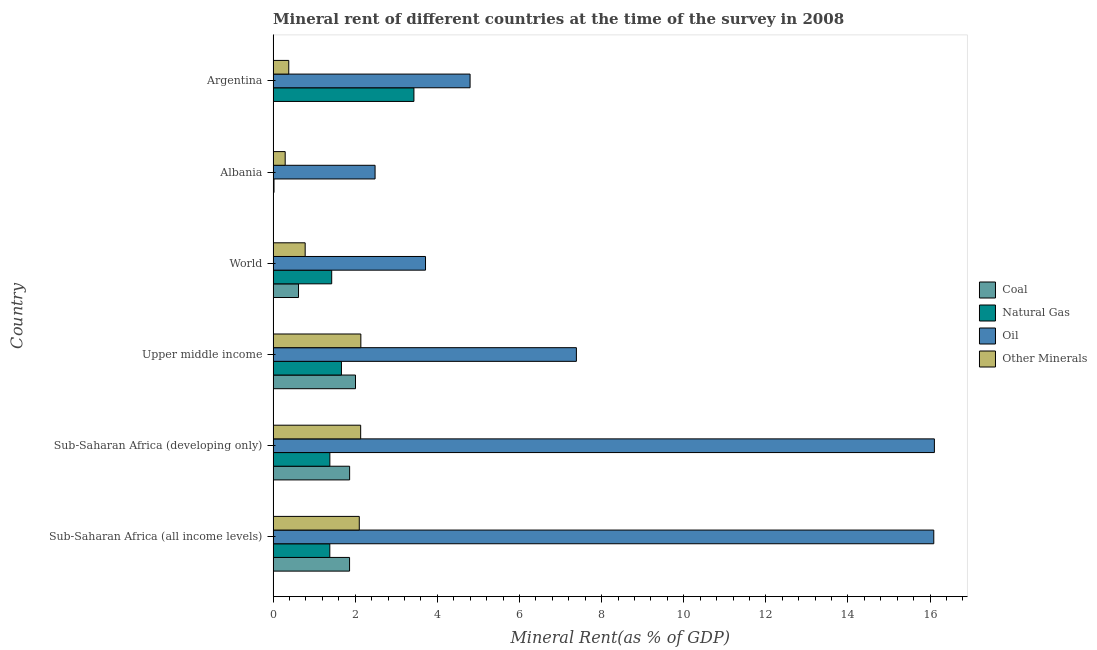How many groups of bars are there?
Your response must be concise. 6. Are the number of bars per tick equal to the number of legend labels?
Your answer should be very brief. Yes. What is the label of the 5th group of bars from the top?
Give a very brief answer. Sub-Saharan Africa (developing only). In how many cases, is the number of bars for a given country not equal to the number of legend labels?
Your answer should be very brief. 0. What is the coal rent in Albania?
Your answer should be very brief. 0. Across all countries, what is the maximum coal rent?
Your answer should be very brief. 2.01. Across all countries, what is the minimum coal rent?
Your response must be concise. 0. In which country was the  rent of other minerals maximum?
Your response must be concise. Upper middle income. In which country was the natural gas rent minimum?
Your response must be concise. Albania. What is the total  rent of other minerals in the graph?
Provide a short and direct response. 7.82. What is the difference between the  rent of other minerals in Argentina and that in Sub-Saharan Africa (all income levels)?
Your answer should be very brief. -1.72. What is the difference between the oil rent in Sub-Saharan Africa (developing only) and the coal rent in Upper middle income?
Provide a succinct answer. 14.1. What is the average oil rent per country?
Offer a very short reply. 8.43. What is the difference between the coal rent and natural gas rent in Sub-Saharan Africa (all income levels)?
Keep it short and to the point. 0.48. In how many countries, is the natural gas rent greater than 7.6 %?
Your answer should be compact. 0. What is the ratio of the oil rent in Sub-Saharan Africa (all income levels) to that in World?
Provide a short and direct response. 4.33. What is the difference between the highest and the second highest  rent of other minerals?
Keep it short and to the point. 0. In how many countries, is the  rent of other minerals greater than the average  rent of other minerals taken over all countries?
Keep it short and to the point. 3. Is the sum of the oil rent in Upper middle income and World greater than the maximum natural gas rent across all countries?
Give a very brief answer. Yes. What does the 1st bar from the top in Argentina represents?
Make the answer very short. Other Minerals. What does the 4th bar from the bottom in Sub-Saharan Africa (developing only) represents?
Provide a succinct answer. Other Minerals. Is it the case that in every country, the sum of the coal rent and natural gas rent is greater than the oil rent?
Provide a succinct answer. No. Are all the bars in the graph horizontal?
Provide a short and direct response. Yes. What is the difference between two consecutive major ticks on the X-axis?
Ensure brevity in your answer.  2. Does the graph contain any zero values?
Keep it short and to the point. No. How are the legend labels stacked?
Keep it short and to the point. Vertical. What is the title of the graph?
Your response must be concise. Mineral rent of different countries at the time of the survey in 2008. Does "Taxes on income" appear as one of the legend labels in the graph?
Your answer should be compact. No. What is the label or title of the X-axis?
Your response must be concise. Mineral Rent(as % of GDP). What is the Mineral Rent(as % of GDP) in Coal in Sub-Saharan Africa (all income levels)?
Offer a terse response. 1.86. What is the Mineral Rent(as % of GDP) in Natural Gas in Sub-Saharan Africa (all income levels)?
Your answer should be very brief. 1.38. What is the Mineral Rent(as % of GDP) in Oil in Sub-Saharan Africa (all income levels)?
Make the answer very short. 16.09. What is the Mineral Rent(as % of GDP) in Other Minerals in Sub-Saharan Africa (all income levels)?
Your response must be concise. 2.1. What is the Mineral Rent(as % of GDP) in Coal in Sub-Saharan Africa (developing only)?
Offer a very short reply. 1.86. What is the Mineral Rent(as % of GDP) in Natural Gas in Sub-Saharan Africa (developing only)?
Offer a terse response. 1.38. What is the Mineral Rent(as % of GDP) of Oil in Sub-Saharan Africa (developing only)?
Offer a very short reply. 16.1. What is the Mineral Rent(as % of GDP) of Other Minerals in Sub-Saharan Africa (developing only)?
Make the answer very short. 2.13. What is the Mineral Rent(as % of GDP) in Coal in Upper middle income?
Your response must be concise. 2.01. What is the Mineral Rent(as % of GDP) in Natural Gas in Upper middle income?
Make the answer very short. 1.66. What is the Mineral Rent(as % of GDP) in Oil in Upper middle income?
Provide a short and direct response. 7.39. What is the Mineral Rent(as % of GDP) of Other Minerals in Upper middle income?
Ensure brevity in your answer.  2.14. What is the Mineral Rent(as % of GDP) in Coal in World?
Your answer should be compact. 0.62. What is the Mineral Rent(as % of GDP) in Natural Gas in World?
Your answer should be compact. 1.43. What is the Mineral Rent(as % of GDP) of Oil in World?
Your answer should be compact. 3.71. What is the Mineral Rent(as % of GDP) in Other Minerals in World?
Your answer should be compact. 0.78. What is the Mineral Rent(as % of GDP) in Coal in Albania?
Offer a terse response. 0. What is the Mineral Rent(as % of GDP) of Natural Gas in Albania?
Offer a terse response. 0.02. What is the Mineral Rent(as % of GDP) of Oil in Albania?
Your answer should be very brief. 2.48. What is the Mineral Rent(as % of GDP) of Other Minerals in Albania?
Ensure brevity in your answer.  0.29. What is the Mineral Rent(as % of GDP) of Coal in Argentina?
Your answer should be compact. 0. What is the Mineral Rent(as % of GDP) of Natural Gas in Argentina?
Ensure brevity in your answer.  3.43. What is the Mineral Rent(as % of GDP) in Oil in Argentina?
Your answer should be compact. 4.8. What is the Mineral Rent(as % of GDP) of Other Minerals in Argentina?
Your answer should be very brief. 0.38. Across all countries, what is the maximum Mineral Rent(as % of GDP) in Coal?
Your response must be concise. 2.01. Across all countries, what is the maximum Mineral Rent(as % of GDP) of Natural Gas?
Give a very brief answer. 3.43. Across all countries, what is the maximum Mineral Rent(as % of GDP) of Oil?
Give a very brief answer. 16.1. Across all countries, what is the maximum Mineral Rent(as % of GDP) of Other Minerals?
Make the answer very short. 2.14. Across all countries, what is the minimum Mineral Rent(as % of GDP) of Coal?
Offer a very short reply. 0. Across all countries, what is the minimum Mineral Rent(as % of GDP) in Natural Gas?
Ensure brevity in your answer.  0.02. Across all countries, what is the minimum Mineral Rent(as % of GDP) of Oil?
Give a very brief answer. 2.48. Across all countries, what is the minimum Mineral Rent(as % of GDP) in Other Minerals?
Offer a very short reply. 0.29. What is the total Mineral Rent(as % of GDP) of Coal in the graph?
Your response must be concise. 6.36. What is the total Mineral Rent(as % of GDP) in Natural Gas in the graph?
Provide a succinct answer. 9.3. What is the total Mineral Rent(as % of GDP) in Oil in the graph?
Offer a very short reply. 50.57. What is the total Mineral Rent(as % of GDP) of Other Minerals in the graph?
Provide a short and direct response. 7.82. What is the difference between the Mineral Rent(as % of GDP) of Coal in Sub-Saharan Africa (all income levels) and that in Sub-Saharan Africa (developing only)?
Give a very brief answer. -0. What is the difference between the Mineral Rent(as % of GDP) of Natural Gas in Sub-Saharan Africa (all income levels) and that in Sub-Saharan Africa (developing only)?
Provide a succinct answer. -0. What is the difference between the Mineral Rent(as % of GDP) of Oil in Sub-Saharan Africa (all income levels) and that in Sub-Saharan Africa (developing only)?
Ensure brevity in your answer.  -0.02. What is the difference between the Mineral Rent(as % of GDP) in Other Minerals in Sub-Saharan Africa (all income levels) and that in Sub-Saharan Africa (developing only)?
Your response must be concise. -0.03. What is the difference between the Mineral Rent(as % of GDP) in Coal in Sub-Saharan Africa (all income levels) and that in Upper middle income?
Give a very brief answer. -0.14. What is the difference between the Mineral Rent(as % of GDP) of Natural Gas in Sub-Saharan Africa (all income levels) and that in Upper middle income?
Offer a terse response. -0.28. What is the difference between the Mineral Rent(as % of GDP) in Oil in Sub-Saharan Africa (all income levels) and that in Upper middle income?
Keep it short and to the point. 8.7. What is the difference between the Mineral Rent(as % of GDP) of Other Minerals in Sub-Saharan Africa (all income levels) and that in Upper middle income?
Ensure brevity in your answer.  -0.04. What is the difference between the Mineral Rent(as % of GDP) in Coal in Sub-Saharan Africa (all income levels) and that in World?
Provide a succinct answer. 1.24. What is the difference between the Mineral Rent(as % of GDP) in Natural Gas in Sub-Saharan Africa (all income levels) and that in World?
Your response must be concise. -0.05. What is the difference between the Mineral Rent(as % of GDP) of Oil in Sub-Saharan Africa (all income levels) and that in World?
Make the answer very short. 12.38. What is the difference between the Mineral Rent(as % of GDP) in Other Minerals in Sub-Saharan Africa (all income levels) and that in World?
Provide a succinct answer. 1.32. What is the difference between the Mineral Rent(as % of GDP) in Coal in Sub-Saharan Africa (all income levels) and that in Albania?
Your answer should be compact. 1.86. What is the difference between the Mineral Rent(as % of GDP) in Natural Gas in Sub-Saharan Africa (all income levels) and that in Albania?
Keep it short and to the point. 1.36. What is the difference between the Mineral Rent(as % of GDP) of Oil in Sub-Saharan Africa (all income levels) and that in Albania?
Your answer should be very brief. 13.61. What is the difference between the Mineral Rent(as % of GDP) in Other Minerals in Sub-Saharan Africa (all income levels) and that in Albania?
Your answer should be compact. 1.8. What is the difference between the Mineral Rent(as % of GDP) in Coal in Sub-Saharan Africa (all income levels) and that in Argentina?
Ensure brevity in your answer.  1.86. What is the difference between the Mineral Rent(as % of GDP) in Natural Gas in Sub-Saharan Africa (all income levels) and that in Argentina?
Your answer should be very brief. -2.05. What is the difference between the Mineral Rent(as % of GDP) in Oil in Sub-Saharan Africa (all income levels) and that in Argentina?
Offer a terse response. 11.29. What is the difference between the Mineral Rent(as % of GDP) of Other Minerals in Sub-Saharan Africa (all income levels) and that in Argentina?
Your response must be concise. 1.72. What is the difference between the Mineral Rent(as % of GDP) in Coal in Sub-Saharan Africa (developing only) and that in Upper middle income?
Keep it short and to the point. -0.14. What is the difference between the Mineral Rent(as % of GDP) of Natural Gas in Sub-Saharan Africa (developing only) and that in Upper middle income?
Your answer should be very brief. -0.28. What is the difference between the Mineral Rent(as % of GDP) in Oil in Sub-Saharan Africa (developing only) and that in Upper middle income?
Provide a succinct answer. 8.72. What is the difference between the Mineral Rent(as % of GDP) in Other Minerals in Sub-Saharan Africa (developing only) and that in Upper middle income?
Provide a succinct answer. -0. What is the difference between the Mineral Rent(as % of GDP) of Coal in Sub-Saharan Africa (developing only) and that in World?
Your answer should be very brief. 1.24. What is the difference between the Mineral Rent(as % of GDP) in Natural Gas in Sub-Saharan Africa (developing only) and that in World?
Ensure brevity in your answer.  -0.04. What is the difference between the Mineral Rent(as % of GDP) in Oil in Sub-Saharan Africa (developing only) and that in World?
Your answer should be compact. 12.39. What is the difference between the Mineral Rent(as % of GDP) in Other Minerals in Sub-Saharan Africa (developing only) and that in World?
Ensure brevity in your answer.  1.35. What is the difference between the Mineral Rent(as % of GDP) of Coal in Sub-Saharan Africa (developing only) and that in Albania?
Give a very brief answer. 1.86. What is the difference between the Mineral Rent(as % of GDP) in Natural Gas in Sub-Saharan Africa (developing only) and that in Albania?
Ensure brevity in your answer.  1.36. What is the difference between the Mineral Rent(as % of GDP) of Oil in Sub-Saharan Africa (developing only) and that in Albania?
Ensure brevity in your answer.  13.62. What is the difference between the Mineral Rent(as % of GDP) in Other Minerals in Sub-Saharan Africa (developing only) and that in Albania?
Make the answer very short. 1.84. What is the difference between the Mineral Rent(as % of GDP) of Coal in Sub-Saharan Africa (developing only) and that in Argentina?
Keep it short and to the point. 1.86. What is the difference between the Mineral Rent(as % of GDP) in Natural Gas in Sub-Saharan Africa (developing only) and that in Argentina?
Offer a terse response. -2.05. What is the difference between the Mineral Rent(as % of GDP) of Oil in Sub-Saharan Africa (developing only) and that in Argentina?
Offer a terse response. 11.31. What is the difference between the Mineral Rent(as % of GDP) in Other Minerals in Sub-Saharan Africa (developing only) and that in Argentina?
Provide a succinct answer. 1.75. What is the difference between the Mineral Rent(as % of GDP) of Coal in Upper middle income and that in World?
Provide a succinct answer. 1.39. What is the difference between the Mineral Rent(as % of GDP) in Natural Gas in Upper middle income and that in World?
Ensure brevity in your answer.  0.24. What is the difference between the Mineral Rent(as % of GDP) of Oil in Upper middle income and that in World?
Your answer should be compact. 3.67. What is the difference between the Mineral Rent(as % of GDP) of Other Minerals in Upper middle income and that in World?
Your answer should be very brief. 1.36. What is the difference between the Mineral Rent(as % of GDP) of Coal in Upper middle income and that in Albania?
Your answer should be very brief. 2. What is the difference between the Mineral Rent(as % of GDP) of Natural Gas in Upper middle income and that in Albania?
Offer a terse response. 1.64. What is the difference between the Mineral Rent(as % of GDP) of Oil in Upper middle income and that in Albania?
Make the answer very short. 4.9. What is the difference between the Mineral Rent(as % of GDP) in Other Minerals in Upper middle income and that in Albania?
Give a very brief answer. 1.84. What is the difference between the Mineral Rent(as % of GDP) of Coal in Upper middle income and that in Argentina?
Give a very brief answer. 2. What is the difference between the Mineral Rent(as % of GDP) in Natural Gas in Upper middle income and that in Argentina?
Provide a short and direct response. -1.77. What is the difference between the Mineral Rent(as % of GDP) in Oil in Upper middle income and that in Argentina?
Provide a succinct answer. 2.59. What is the difference between the Mineral Rent(as % of GDP) in Other Minerals in Upper middle income and that in Argentina?
Provide a succinct answer. 1.76. What is the difference between the Mineral Rent(as % of GDP) of Coal in World and that in Albania?
Ensure brevity in your answer.  0.62. What is the difference between the Mineral Rent(as % of GDP) of Natural Gas in World and that in Albania?
Keep it short and to the point. 1.41. What is the difference between the Mineral Rent(as % of GDP) in Oil in World and that in Albania?
Make the answer very short. 1.23. What is the difference between the Mineral Rent(as % of GDP) of Other Minerals in World and that in Albania?
Ensure brevity in your answer.  0.49. What is the difference between the Mineral Rent(as % of GDP) in Coal in World and that in Argentina?
Provide a succinct answer. 0.62. What is the difference between the Mineral Rent(as % of GDP) in Natural Gas in World and that in Argentina?
Provide a short and direct response. -2. What is the difference between the Mineral Rent(as % of GDP) of Oil in World and that in Argentina?
Your answer should be very brief. -1.09. What is the difference between the Mineral Rent(as % of GDP) in Other Minerals in World and that in Argentina?
Provide a succinct answer. 0.4. What is the difference between the Mineral Rent(as % of GDP) in Coal in Albania and that in Argentina?
Provide a short and direct response. 0. What is the difference between the Mineral Rent(as % of GDP) in Natural Gas in Albania and that in Argentina?
Offer a very short reply. -3.41. What is the difference between the Mineral Rent(as % of GDP) in Oil in Albania and that in Argentina?
Make the answer very short. -2.31. What is the difference between the Mineral Rent(as % of GDP) in Other Minerals in Albania and that in Argentina?
Your answer should be very brief. -0.09. What is the difference between the Mineral Rent(as % of GDP) in Coal in Sub-Saharan Africa (all income levels) and the Mineral Rent(as % of GDP) in Natural Gas in Sub-Saharan Africa (developing only)?
Offer a terse response. 0.48. What is the difference between the Mineral Rent(as % of GDP) of Coal in Sub-Saharan Africa (all income levels) and the Mineral Rent(as % of GDP) of Oil in Sub-Saharan Africa (developing only)?
Make the answer very short. -14.24. What is the difference between the Mineral Rent(as % of GDP) in Coal in Sub-Saharan Africa (all income levels) and the Mineral Rent(as % of GDP) in Other Minerals in Sub-Saharan Africa (developing only)?
Make the answer very short. -0.27. What is the difference between the Mineral Rent(as % of GDP) in Natural Gas in Sub-Saharan Africa (all income levels) and the Mineral Rent(as % of GDP) in Oil in Sub-Saharan Africa (developing only)?
Provide a short and direct response. -14.72. What is the difference between the Mineral Rent(as % of GDP) in Natural Gas in Sub-Saharan Africa (all income levels) and the Mineral Rent(as % of GDP) in Other Minerals in Sub-Saharan Africa (developing only)?
Provide a succinct answer. -0.75. What is the difference between the Mineral Rent(as % of GDP) in Oil in Sub-Saharan Africa (all income levels) and the Mineral Rent(as % of GDP) in Other Minerals in Sub-Saharan Africa (developing only)?
Provide a succinct answer. 13.96. What is the difference between the Mineral Rent(as % of GDP) in Coal in Sub-Saharan Africa (all income levels) and the Mineral Rent(as % of GDP) in Natural Gas in Upper middle income?
Your answer should be very brief. 0.2. What is the difference between the Mineral Rent(as % of GDP) of Coal in Sub-Saharan Africa (all income levels) and the Mineral Rent(as % of GDP) of Oil in Upper middle income?
Provide a succinct answer. -5.52. What is the difference between the Mineral Rent(as % of GDP) in Coal in Sub-Saharan Africa (all income levels) and the Mineral Rent(as % of GDP) in Other Minerals in Upper middle income?
Make the answer very short. -0.27. What is the difference between the Mineral Rent(as % of GDP) of Natural Gas in Sub-Saharan Africa (all income levels) and the Mineral Rent(as % of GDP) of Oil in Upper middle income?
Ensure brevity in your answer.  -6.01. What is the difference between the Mineral Rent(as % of GDP) of Natural Gas in Sub-Saharan Africa (all income levels) and the Mineral Rent(as % of GDP) of Other Minerals in Upper middle income?
Give a very brief answer. -0.76. What is the difference between the Mineral Rent(as % of GDP) in Oil in Sub-Saharan Africa (all income levels) and the Mineral Rent(as % of GDP) in Other Minerals in Upper middle income?
Provide a succinct answer. 13.95. What is the difference between the Mineral Rent(as % of GDP) of Coal in Sub-Saharan Africa (all income levels) and the Mineral Rent(as % of GDP) of Natural Gas in World?
Your response must be concise. 0.43. What is the difference between the Mineral Rent(as % of GDP) in Coal in Sub-Saharan Africa (all income levels) and the Mineral Rent(as % of GDP) in Oil in World?
Your answer should be very brief. -1.85. What is the difference between the Mineral Rent(as % of GDP) in Coal in Sub-Saharan Africa (all income levels) and the Mineral Rent(as % of GDP) in Other Minerals in World?
Provide a short and direct response. 1.08. What is the difference between the Mineral Rent(as % of GDP) in Natural Gas in Sub-Saharan Africa (all income levels) and the Mineral Rent(as % of GDP) in Oil in World?
Provide a short and direct response. -2.33. What is the difference between the Mineral Rent(as % of GDP) in Oil in Sub-Saharan Africa (all income levels) and the Mineral Rent(as % of GDP) in Other Minerals in World?
Ensure brevity in your answer.  15.31. What is the difference between the Mineral Rent(as % of GDP) of Coal in Sub-Saharan Africa (all income levels) and the Mineral Rent(as % of GDP) of Natural Gas in Albania?
Your response must be concise. 1.84. What is the difference between the Mineral Rent(as % of GDP) in Coal in Sub-Saharan Africa (all income levels) and the Mineral Rent(as % of GDP) in Oil in Albania?
Keep it short and to the point. -0.62. What is the difference between the Mineral Rent(as % of GDP) of Coal in Sub-Saharan Africa (all income levels) and the Mineral Rent(as % of GDP) of Other Minerals in Albania?
Keep it short and to the point. 1.57. What is the difference between the Mineral Rent(as % of GDP) in Natural Gas in Sub-Saharan Africa (all income levels) and the Mineral Rent(as % of GDP) in Oil in Albania?
Your answer should be compact. -1.1. What is the difference between the Mineral Rent(as % of GDP) of Natural Gas in Sub-Saharan Africa (all income levels) and the Mineral Rent(as % of GDP) of Other Minerals in Albania?
Offer a very short reply. 1.09. What is the difference between the Mineral Rent(as % of GDP) of Oil in Sub-Saharan Africa (all income levels) and the Mineral Rent(as % of GDP) of Other Minerals in Albania?
Offer a very short reply. 15.8. What is the difference between the Mineral Rent(as % of GDP) in Coal in Sub-Saharan Africa (all income levels) and the Mineral Rent(as % of GDP) in Natural Gas in Argentina?
Your response must be concise. -1.57. What is the difference between the Mineral Rent(as % of GDP) in Coal in Sub-Saharan Africa (all income levels) and the Mineral Rent(as % of GDP) in Oil in Argentina?
Offer a very short reply. -2.94. What is the difference between the Mineral Rent(as % of GDP) in Coal in Sub-Saharan Africa (all income levels) and the Mineral Rent(as % of GDP) in Other Minerals in Argentina?
Ensure brevity in your answer.  1.48. What is the difference between the Mineral Rent(as % of GDP) in Natural Gas in Sub-Saharan Africa (all income levels) and the Mineral Rent(as % of GDP) in Oil in Argentina?
Your response must be concise. -3.42. What is the difference between the Mineral Rent(as % of GDP) in Natural Gas in Sub-Saharan Africa (all income levels) and the Mineral Rent(as % of GDP) in Other Minerals in Argentina?
Ensure brevity in your answer.  1. What is the difference between the Mineral Rent(as % of GDP) in Oil in Sub-Saharan Africa (all income levels) and the Mineral Rent(as % of GDP) in Other Minerals in Argentina?
Ensure brevity in your answer.  15.71. What is the difference between the Mineral Rent(as % of GDP) of Coal in Sub-Saharan Africa (developing only) and the Mineral Rent(as % of GDP) of Natural Gas in Upper middle income?
Provide a short and direct response. 0.2. What is the difference between the Mineral Rent(as % of GDP) of Coal in Sub-Saharan Africa (developing only) and the Mineral Rent(as % of GDP) of Oil in Upper middle income?
Offer a terse response. -5.52. What is the difference between the Mineral Rent(as % of GDP) of Coal in Sub-Saharan Africa (developing only) and the Mineral Rent(as % of GDP) of Other Minerals in Upper middle income?
Your response must be concise. -0.27. What is the difference between the Mineral Rent(as % of GDP) of Natural Gas in Sub-Saharan Africa (developing only) and the Mineral Rent(as % of GDP) of Oil in Upper middle income?
Provide a succinct answer. -6. What is the difference between the Mineral Rent(as % of GDP) in Natural Gas in Sub-Saharan Africa (developing only) and the Mineral Rent(as % of GDP) in Other Minerals in Upper middle income?
Offer a very short reply. -0.75. What is the difference between the Mineral Rent(as % of GDP) in Oil in Sub-Saharan Africa (developing only) and the Mineral Rent(as % of GDP) in Other Minerals in Upper middle income?
Provide a succinct answer. 13.97. What is the difference between the Mineral Rent(as % of GDP) in Coal in Sub-Saharan Africa (developing only) and the Mineral Rent(as % of GDP) in Natural Gas in World?
Offer a very short reply. 0.44. What is the difference between the Mineral Rent(as % of GDP) in Coal in Sub-Saharan Africa (developing only) and the Mineral Rent(as % of GDP) in Oil in World?
Offer a terse response. -1.85. What is the difference between the Mineral Rent(as % of GDP) in Coal in Sub-Saharan Africa (developing only) and the Mineral Rent(as % of GDP) in Other Minerals in World?
Provide a succinct answer. 1.08. What is the difference between the Mineral Rent(as % of GDP) in Natural Gas in Sub-Saharan Africa (developing only) and the Mineral Rent(as % of GDP) in Oil in World?
Keep it short and to the point. -2.33. What is the difference between the Mineral Rent(as % of GDP) of Natural Gas in Sub-Saharan Africa (developing only) and the Mineral Rent(as % of GDP) of Other Minerals in World?
Make the answer very short. 0.6. What is the difference between the Mineral Rent(as % of GDP) of Oil in Sub-Saharan Africa (developing only) and the Mineral Rent(as % of GDP) of Other Minerals in World?
Your response must be concise. 15.32. What is the difference between the Mineral Rent(as % of GDP) in Coal in Sub-Saharan Africa (developing only) and the Mineral Rent(as % of GDP) in Natural Gas in Albania?
Your answer should be very brief. 1.84. What is the difference between the Mineral Rent(as % of GDP) in Coal in Sub-Saharan Africa (developing only) and the Mineral Rent(as % of GDP) in Oil in Albania?
Your answer should be compact. -0.62. What is the difference between the Mineral Rent(as % of GDP) of Coal in Sub-Saharan Africa (developing only) and the Mineral Rent(as % of GDP) of Other Minerals in Albania?
Your answer should be very brief. 1.57. What is the difference between the Mineral Rent(as % of GDP) in Natural Gas in Sub-Saharan Africa (developing only) and the Mineral Rent(as % of GDP) in Oil in Albania?
Provide a short and direct response. -1.1. What is the difference between the Mineral Rent(as % of GDP) in Natural Gas in Sub-Saharan Africa (developing only) and the Mineral Rent(as % of GDP) in Other Minerals in Albania?
Provide a succinct answer. 1.09. What is the difference between the Mineral Rent(as % of GDP) in Oil in Sub-Saharan Africa (developing only) and the Mineral Rent(as % of GDP) in Other Minerals in Albania?
Your answer should be compact. 15.81. What is the difference between the Mineral Rent(as % of GDP) of Coal in Sub-Saharan Africa (developing only) and the Mineral Rent(as % of GDP) of Natural Gas in Argentina?
Offer a very short reply. -1.57. What is the difference between the Mineral Rent(as % of GDP) of Coal in Sub-Saharan Africa (developing only) and the Mineral Rent(as % of GDP) of Oil in Argentina?
Your answer should be very brief. -2.93. What is the difference between the Mineral Rent(as % of GDP) of Coal in Sub-Saharan Africa (developing only) and the Mineral Rent(as % of GDP) of Other Minerals in Argentina?
Offer a very short reply. 1.48. What is the difference between the Mineral Rent(as % of GDP) of Natural Gas in Sub-Saharan Africa (developing only) and the Mineral Rent(as % of GDP) of Oil in Argentina?
Give a very brief answer. -3.42. What is the difference between the Mineral Rent(as % of GDP) of Natural Gas in Sub-Saharan Africa (developing only) and the Mineral Rent(as % of GDP) of Other Minerals in Argentina?
Keep it short and to the point. 1. What is the difference between the Mineral Rent(as % of GDP) in Oil in Sub-Saharan Africa (developing only) and the Mineral Rent(as % of GDP) in Other Minerals in Argentina?
Offer a terse response. 15.72. What is the difference between the Mineral Rent(as % of GDP) in Coal in Upper middle income and the Mineral Rent(as % of GDP) in Natural Gas in World?
Keep it short and to the point. 0.58. What is the difference between the Mineral Rent(as % of GDP) of Coal in Upper middle income and the Mineral Rent(as % of GDP) of Oil in World?
Provide a short and direct response. -1.71. What is the difference between the Mineral Rent(as % of GDP) in Coal in Upper middle income and the Mineral Rent(as % of GDP) in Other Minerals in World?
Your answer should be very brief. 1.23. What is the difference between the Mineral Rent(as % of GDP) of Natural Gas in Upper middle income and the Mineral Rent(as % of GDP) of Oil in World?
Offer a terse response. -2.05. What is the difference between the Mineral Rent(as % of GDP) in Natural Gas in Upper middle income and the Mineral Rent(as % of GDP) in Other Minerals in World?
Provide a short and direct response. 0.88. What is the difference between the Mineral Rent(as % of GDP) in Oil in Upper middle income and the Mineral Rent(as % of GDP) in Other Minerals in World?
Your response must be concise. 6.61. What is the difference between the Mineral Rent(as % of GDP) in Coal in Upper middle income and the Mineral Rent(as % of GDP) in Natural Gas in Albania?
Ensure brevity in your answer.  1.98. What is the difference between the Mineral Rent(as % of GDP) of Coal in Upper middle income and the Mineral Rent(as % of GDP) of Oil in Albania?
Offer a terse response. -0.48. What is the difference between the Mineral Rent(as % of GDP) in Coal in Upper middle income and the Mineral Rent(as % of GDP) in Other Minerals in Albania?
Your answer should be compact. 1.71. What is the difference between the Mineral Rent(as % of GDP) in Natural Gas in Upper middle income and the Mineral Rent(as % of GDP) in Oil in Albania?
Make the answer very short. -0.82. What is the difference between the Mineral Rent(as % of GDP) of Natural Gas in Upper middle income and the Mineral Rent(as % of GDP) of Other Minerals in Albania?
Offer a very short reply. 1.37. What is the difference between the Mineral Rent(as % of GDP) in Oil in Upper middle income and the Mineral Rent(as % of GDP) in Other Minerals in Albania?
Your response must be concise. 7.09. What is the difference between the Mineral Rent(as % of GDP) of Coal in Upper middle income and the Mineral Rent(as % of GDP) of Natural Gas in Argentina?
Ensure brevity in your answer.  -1.42. What is the difference between the Mineral Rent(as % of GDP) of Coal in Upper middle income and the Mineral Rent(as % of GDP) of Oil in Argentina?
Provide a succinct answer. -2.79. What is the difference between the Mineral Rent(as % of GDP) in Coal in Upper middle income and the Mineral Rent(as % of GDP) in Other Minerals in Argentina?
Provide a succinct answer. 1.63. What is the difference between the Mineral Rent(as % of GDP) in Natural Gas in Upper middle income and the Mineral Rent(as % of GDP) in Oil in Argentina?
Ensure brevity in your answer.  -3.13. What is the difference between the Mineral Rent(as % of GDP) of Natural Gas in Upper middle income and the Mineral Rent(as % of GDP) of Other Minerals in Argentina?
Your answer should be compact. 1.28. What is the difference between the Mineral Rent(as % of GDP) of Oil in Upper middle income and the Mineral Rent(as % of GDP) of Other Minerals in Argentina?
Your response must be concise. 7. What is the difference between the Mineral Rent(as % of GDP) of Coal in World and the Mineral Rent(as % of GDP) of Natural Gas in Albania?
Your answer should be compact. 0.6. What is the difference between the Mineral Rent(as % of GDP) of Coal in World and the Mineral Rent(as % of GDP) of Oil in Albania?
Provide a succinct answer. -1.86. What is the difference between the Mineral Rent(as % of GDP) of Coal in World and the Mineral Rent(as % of GDP) of Other Minerals in Albania?
Ensure brevity in your answer.  0.32. What is the difference between the Mineral Rent(as % of GDP) of Natural Gas in World and the Mineral Rent(as % of GDP) of Oil in Albania?
Your answer should be very brief. -1.06. What is the difference between the Mineral Rent(as % of GDP) of Natural Gas in World and the Mineral Rent(as % of GDP) of Other Minerals in Albania?
Your answer should be very brief. 1.13. What is the difference between the Mineral Rent(as % of GDP) in Oil in World and the Mineral Rent(as % of GDP) in Other Minerals in Albania?
Your response must be concise. 3.42. What is the difference between the Mineral Rent(as % of GDP) of Coal in World and the Mineral Rent(as % of GDP) of Natural Gas in Argentina?
Provide a short and direct response. -2.81. What is the difference between the Mineral Rent(as % of GDP) in Coal in World and the Mineral Rent(as % of GDP) in Oil in Argentina?
Provide a succinct answer. -4.18. What is the difference between the Mineral Rent(as % of GDP) in Coal in World and the Mineral Rent(as % of GDP) in Other Minerals in Argentina?
Your response must be concise. 0.24. What is the difference between the Mineral Rent(as % of GDP) of Natural Gas in World and the Mineral Rent(as % of GDP) of Oil in Argentina?
Offer a very short reply. -3.37. What is the difference between the Mineral Rent(as % of GDP) of Natural Gas in World and the Mineral Rent(as % of GDP) of Other Minerals in Argentina?
Offer a very short reply. 1.05. What is the difference between the Mineral Rent(as % of GDP) in Oil in World and the Mineral Rent(as % of GDP) in Other Minerals in Argentina?
Give a very brief answer. 3.33. What is the difference between the Mineral Rent(as % of GDP) of Coal in Albania and the Mineral Rent(as % of GDP) of Natural Gas in Argentina?
Ensure brevity in your answer.  -3.43. What is the difference between the Mineral Rent(as % of GDP) in Coal in Albania and the Mineral Rent(as % of GDP) in Oil in Argentina?
Make the answer very short. -4.79. What is the difference between the Mineral Rent(as % of GDP) of Coal in Albania and the Mineral Rent(as % of GDP) of Other Minerals in Argentina?
Provide a short and direct response. -0.38. What is the difference between the Mineral Rent(as % of GDP) in Natural Gas in Albania and the Mineral Rent(as % of GDP) in Oil in Argentina?
Offer a terse response. -4.78. What is the difference between the Mineral Rent(as % of GDP) in Natural Gas in Albania and the Mineral Rent(as % of GDP) in Other Minerals in Argentina?
Keep it short and to the point. -0.36. What is the difference between the Mineral Rent(as % of GDP) of Oil in Albania and the Mineral Rent(as % of GDP) of Other Minerals in Argentina?
Give a very brief answer. 2.1. What is the average Mineral Rent(as % of GDP) in Coal per country?
Offer a very short reply. 1.06. What is the average Mineral Rent(as % of GDP) in Natural Gas per country?
Offer a very short reply. 1.55. What is the average Mineral Rent(as % of GDP) of Oil per country?
Give a very brief answer. 8.43. What is the average Mineral Rent(as % of GDP) of Other Minerals per country?
Offer a terse response. 1.3. What is the difference between the Mineral Rent(as % of GDP) in Coal and Mineral Rent(as % of GDP) in Natural Gas in Sub-Saharan Africa (all income levels)?
Your response must be concise. 0.48. What is the difference between the Mineral Rent(as % of GDP) of Coal and Mineral Rent(as % of GDP) of Oil in Sub-Saharan Africa (all income levels)?
Offer a terse response. -14.23. What is the difference between the Mineral Rent(as % of GDP) in Coal and Mineral Rent(as % of GDP) in Other Minerals in Sub-Saharan Africa (all income levels)?
Your response must be concise. -0.24. What is the difference between the Mineral Rent(as % of GDP) in Natural Gas and Mineral Rent(as % of GDP) in Oil in Sub-Saharan Africa (all income levels)?
Your answer should be compact. -14.71. What is the difference between the Mineral Rent(as % of GDP) of Natural Gas and Mineral Rent(as % of GDP) of Other Minerals in Sub-Saharan Africa (all income levels)?
Make the answer very short. -0.72. What is the difference between the Mineral Rent(as % of GDP) of Oil and Mineral Rent(as % of GDP) of Other Minerals in Sub-Saharan Africa (all income levels)?
Your response must be concise. 13.99. What is the difference between the Mineral Rent(as % of GDP) of Coal and Mineral Rent(as % of GDP) of Natural Gas in Sub-Saharan Africa (developing only)?
Give a very brief answer. 0.48. What is the difference between the Mineral Rent(as % of GDP) in Coal and Mineral Rent(as % of GDP) in Oil in Sub-Saharan Africa (developing only)?
Ensure brevity in your answer.  -14.24. What is the difference between the Mineral Rent(as % of GDP) in Coal and Mineral Rent(as % of GDP) in Other Minerals in Sub-Saharan Africa (developing only)?
Your response must be concise. -0.27. What is the difference between the Mineral Rent(as % of GDP) in Natural Gas and Mineral Rent(as % of GDP) in Oil in Sub-Saharan Africa (developing only)?
Make the answer very short. -14.72. What is the difference between the Mineral Rent(as % of GDP) of Natural Gas and Mineral Rent(as % of GDP) of Other Minerals in Sub-Saharan Africa (developing only)?
Keep it short and to the point. -0.75. What is the difference between the Mineral Rent(as % of GDP) of Oil and Mineral Rent(as % of GDP) of Other Minerals in Sub-Saharan Africa (developing only)?
Offer a terse response. 13.97. What is the difference between the Mineral Rent(as % of GDP) of Coal and Mineral Rent(as % of GDP) of Natural Gas in Upper middle income?
Your response must be concise. 0.34. What is the difference between the Mineral Rent(as % of GDP) of Coal and Mineral Rent(as % of GDP) of Oil in Upper middle income?
Make the answer very short. -5.38. What is the difference between the Mineral Rent(as % of GDP) of Coal and Mineral Rent(as % of GDP) of Other Minerals in Upper middle income?
Give a very brief answer. -0.13. What is the difference between the Mineral Rent(as % of GDP) in Natural Gas and Mineral Rent(as % of GDP) in Oil in Upper middle income?
Ensure brevity in your answer.  -5.72. What is the difference between the Mineral Rent(as % of GDP) of Natural Gas and Mineral Rent(as % of GDP) of Other Minerals in Upper middle income?
Your answer should be very brief. -0.47. What is the difference between the Mineral Rent(as % of GDP) of Oil and Mineral Rent(as % of GDP) of Other Minerals in Upper middle income?
Make the answer very short. 5.25. What is the difference between the Mineral Rent(as % of GDP) of Coal and Mineral Rent(as % of GDP) of Natural Gas in World?
Ensure brevity in your answer.  -0.81. What is the difference between the Mineral Rent(as % of GDP) in Coal and Mineral Rent(as % of GDP) in Oil in World?
Offer a terse response. -3.09. What is the difference between the Mineral Rent(as % of GDP) in Coal and Mineral Rent(as % of GDP) in Other Minerals in World?
Provide a succinct answer. -0.16. What is the difference between the Mineral Rent(as % of GDP) of Natural Gas and Mineral Rent(as % of GDP) of Oil in World?
Offer a very short reply. -2.29. What is the difference between the Mineral Rent(as % of GDP) of Natural Gas and Mineral Rent(as % of GDP) of Other Minerals in World?
Provide a succinct answer. 0.65. What is the difference between the Mineral Rent(as % of GDP) in Oil and Mineral Rent(as % of GDP) in Other Minerals in World?
Offer a terse response. 2.93. What is the difference between the Mineral Rent(as % of GDP) of Coal and Mineral Rent(as % of GDP) of Natural Gas in Albania?
Offer a terse response. -0.02. What is the difference between the Mineral Rent(as % of GDP) of Coal and Mineral Rent(as % of GDP) of Oil in Albania?
Make the answer very short. -2.48. What is the difference between the Mineral Rent(as % of GDP) of Coal and Mineral Rent(as % of GDP) of Other Minerals in Albania?
Make the answer very short. -0.29. What is the difference between the Mineral Rent(as % of GDP) in Natural Gas and Mineral Rent(as % of GDP) in Oil in Albania?
Keep it short and to the point. -2.46. What is the difference between the Mineral Rent(as % of GDP) of Natural Gas and Mineral Rent(as % of GDP) of Other Minerals in Albania?
Your response must be concise. -0.27. What is the difference between the Mineral Rent(as % of GDP) in Oil and Mineral Rent(as % of GDP) in Other Minerals in Albania?
Provide a succinct answer. 2.19. What is the difference between the Mineral Rent(as % of GDP) of Coal and Mineral Rent(as % of GDP) of Natural Gas in Argentina?
Offer a very short reply. -3.43. What is the difference between the Mineral Rent(as % of GDP) in Coal and Mineral Rent(as % of GDP) in Oil in Argentina?
Your response must be concise. -4.79. What is the difference between the Mineral Rent(as % of GDP) in Coal and Mineral Rent(as % of GDP) in Other Minerals in Argentina?
Offer a terse response. -0.38. What is the difference between the Mineral Rent(as % of GDP) of Natural Gas and Mineral Rent(as % of GDP) of Oil in Argentina?
Provide a succinct answer. -1.37. What is the difference between the Mineral Rent(as % of GDP) of Natural Gas and Mineral Rent(as % of GDP) of Other Minerals in Argentina?
Ensure brevity in your answer.  3.05. What is the difference between the Mineral Rent(as % of GDP) in Oil and Mineral Rent(as % of GDP) in Other Minerals in Argentina?
Offer a terse response. 4.42. What is the ratio of the Mineral Rent(as % of GDP) of Oil in Sub-Saharan Africa (all income levels) to that in Sub-Saharan Africa (developing only)?
Give a very brief answer. 1. What is the ratio of the Mineral Rent(as % of GDP) of Other Minerals in Sub-Saharan Africa (all income levels) to that in Sub-Saharan Africa (developing only)?
Offer a terse response. 0.98. What is the ratio of the Mineral Rent(as % of GDP) in Coal in Sub-Saharan Africa (all income levels) to that in Upper middle income?
Your response must be concise. 0.93. What is the ratio of the Mineral Rent(as % of GDP) in Natural Gas in Sub-Saharan Africa (all income levels) to that in Upper middle income?
Provide a succinct answer. 0.83. What is the ratio of the Mineral Rent(as % of GDP) in Oil in Sub-Saharan Africa (all income levels) to that in Upper middle income?
Keep it short and to the point. 2.18. What is the ratio of the Mineral Rent(as % of GDP) of Other Minerals in Sub-Saharan Africa (all income levels) to that in Upper middle income?
Offer a terse response. 0.98. What is the ratio of the Mineral Rent(as % of GDP) in Coal in Sub-Saharan Africa (all income levels) to that in World?
Your answer should be compact. 3.01. What is the ratio of the Mineral Rent(as % of GDP) of Natural Gas in Sub-Saharan Africa (all income levels) to that in World?
Offer a terse response. 0.97. What is the ratio of the Mineral Rent(as % of GDP) in Oil in Sub-Saharan Africa (all income levels) to that in World?
Provide a succinct answer. 4.33. What is the ratio of the Mineral Rent(as % of GDP) in Other Minerals in Sub-Saharan Africa (all income levels) to that in World?
Provide a short and direct response. 2.69. What is the ratio of the Mineral Rent(as % of GDP) in Coal in Sub-Saharan Africa (all income levels) to that in Albania?
Your answer should be compact. 638.33. What is the ratio of the Mineral Rent(as % of GDP) of Natural Gas in Sub-Saharan Africa (all income levels) to that in Albania?
Your answer should be compact. 64.36. What is the ratio of the Mineral Rent(as % of GDP) of Oil in Sub-Saharan Africa (all income levels) to that in Albania?
Offer a terse response. 6.48. What is the ratio of the Mineral Rent(as % of GDP) of Other Minerals in Sub-Saharan Africa (all income levels) to that in Albania?
Give a very brief answer. 7.14. What is the ratio of the Mineral Rent(as % of GDP) of Coal in Sub-Saharan Africa (all income levels) to that in Argentina?
Ensure brevity in your answer.  711.8. What is the ratio of the Mineral Rent(as % of GDP) in Natural Gas in Sub-Saharan Africa (all income levels) to that in Argentina?
Your answer should be very brief. 0.4. What is the ratio of the Mineral Rent(as % of GDP) in Oil in Sub-Saharan Africa (all income levels) to that in Argentina?
Make the answer very short. 3.35. What is the ratio of the Mineral Rent(as % of GDP) in Other Minerals in Sub-Saharan Africa (all income levels) to that in Argentina?
Your answer should be very brief. 5.51. What is the ratio of the Mineral Rent(as % of GDP) of Coal in Sub-Saharan Africa (developing only) to that in Upper middle income?
Provide a short and direct response. 0.93. What is the ratio of the Mineral Rent(as % of GDP) of Natural Gas in Sub-Saharan Africa (developing only) to that in Upper middle income?
Keep it short and to the point. 0.83. What is the ratio of the Mineral Rent(as % of GDP) in Oil in Sub-Saharan Africa (developing only) to that in Upper middle income?
Offer a terse response. 2.18. What is the ratio of the Mineral Rent(as % of GDP) of Coal in Sub-Saharan Africa (developing only) to that in World?
Your answer should be very brief. 3.01. What is the ratio of the Mineral Rent(as % of GDP) in Natural Gas in Sub-Saharan Africa (developing only) to that in World?
Your answer should be very brief. 0.97. What is the ratio of the Mineral Rent(as % of GDP) of Oil in Sub-Saharan Africa (developing only) to that in World?
Provide a short and direct response. 4.34. What is the ratio of the Mineral Rent(as % of GDP) in Other Minerals in Sub-Saharan Africa (developing only) to that in World?
Provide a succinct answer. 2.73. What is the ratio of the Mineral Rent(as % of GDP) of Coal in Sub-Saharan Africa (developing only) to that in Albania?
Make the answer very short. 638.92. What is the ratio of the Mineral Rent(as % of GDP) in Natural Gas in Sub-Saharan Africa (developing only) to that in Albania?
Your response must be concise. 64.42. What is the ratio of the Mineral Rent(as % of GDP) in Oil in Sub-Saharan Africa (developing only) to that in Albania?
Your answer should be very brief. 6.49. What is the ratio of the Mineral Rent(as % of GDP) of Other Minerals in Sub-Saharan Africa (developing only) to that in Albania?
Keep it short and to the point. 7.26. What is the ratio of the Mineral Rent(as % of GDP) in Coal in Sub-Saharan Africa (developing only) to that in Argentina?
Offer a very short reply. 712.46. What is the ratio of the Mineral Rent(as % of GDP) of Natural Gas in Sub-Saharan Africa (developing only) to that in Argentina?
Provide a succinct answer. 0.4. What is the ratio of the Mineral Rent(as % of GDP) in Oil in Sub-Saharan Africa (developing only) to that in Argentina?
Offer a terse response. 3.36. What is the ratio of the Mineral Rent(as % of GDP) in Other Minerals in Sub-Saharan Africa (developing only) to that in Argentina?
Your response must be concise. 5.6. What is the ratio of the Mineral Rent(as % of GDP) of Coal in Upper middle income to that in World?
Keep it short and to the point. 3.24. What is the ratio of the Mineral Rent(as % of GDP) in Natural Gas in Upper middle income to that in World?
Your response must be concise. 1.17. What is the ratio of the Mineral Rent(as % of GDP) in Oil in Upper middle income to that in World?
Make the answer very short. 1.99. What is the ratio of the Mineral Rent(as % of GDP) of Other Minerals in Upper middle income to that in World?
Keep it short and to the point. 2.74. What is the ratio of the Mineral Rent(as % of GDP) of Coal in Upper middle income to that in Albania?
Give a very brief answer. 688. What is the ratio of the Mineral Rent(as % of GDP) in Natural Gas in Upper middle income to that in Albania?
Offer a very short reply. 77.56. What is the ratio of the Mineral Rent(as % of GDP) in Oil in Upper middle income to that in Albania?
Your response must be concise. 2.97. What is the ratio of the Mineral Rent(as % of GDP) of Other Minerals in Upper middle income to that in Albania?
Provide a short and direct response. 7.27. What is the ratio of the Mineral Rent(as % of GDP) in Coal in Upper middle income to that in Argentina?
Offer a terse response. 767.18. What is the ratio of the Mineral Rent(as % of GDP) in Natural Gas in Upper middle income to that in Argentina?
Provide a succinct answer. 0.49. What is the ratio of the Mineral Rent(as % of GDP) in Oil in Upper middle income to that in Argentina?
Offer a terse response. 1.54. What is the ratio of the Mineral Rent(as % of GDP) in Other Minerals in Upper middle income to that in Argentina?
Give a very brief answer. 5.61. What is the ratio of the Mineral Rent(as % of GDP) of Coal in World to that in Albania?
Your answer should be very brief. 212.13. What is the ratio of the Mineral Rent(as % of GDP) of Natural Gas in World to that in Albania?
Offer a very short reply. 66.5. What is the ratio of the Mineral Rent(as % of GDP) of Oil in World to that in Albania?
Make the answer very short. 1.49. What is the ratio of the Mineral Rent(as % of GDP) of Other Minerals in World to that in Albania?
Your answer should be very brief. 2.66. What is the ratio of the Mineral Rent(as % of GDP) in Coal in World to that in Argentina?
Offer a very short reply. 236.55. What is the ratio of the Mineral Rent(as % of GDP) in Natural Gas in World to that in Argentina?
Ensure brevity in your answer.  0.42. What is the ratio of the Mineral Rent(as % of GDP) in Oil in World to that in Argentina?
Your response must be concise. 0.77. What is the ratio of the Mineral Rent(as % of GDP) of Other Minerals in World to that in Argentina?
Your answer should be very brief. 2.05. What is the ratio of the Mineral Rent(as % of GDP) of Coal in Albania to that in Argentina?
Give a very brief answer. 1.12. What is the ratio of the Mineral Rent(as % of GDP) in Natural Gas in Albania to that in Argentina?
Provide a short and direct response. 0.01. What is the ratio of the Mineral Rent(as % of GDP) in Oil in Albania to that in Argentina?
Make the answer very short. 0.52. What is the ratio of the Mineral Rent(as % of GDP) of Other Minerals in Albania to that in Argentina?
Provide a succinct answer. 0.77. What is the difference between the highest and the second highest Mineral Rent(as % of GDP) in Coal?
Make the answer very short. 0.14. What is the difference between the highest and the second highest Mineral Rent(as % of GDP) in Natural Gas?
Ensure brevity in your answer.  1.77. What is the difference between the highest and the second highest Mineral Rent(as % of GDP) in Oil?
Provide a succinct answer. 0.02. What is the difference between the highest and the second highest Mineral Rent(as % of GDP) in Other Minerals?
Ensure brevity in your answer.  0. What is the difference between the highest and the lowest Mineral Rent(as % of GDP) of Coal?
Give a very brief answer. 2. What is the difference between the highest and the lowest Mineral Rent(as % of GDP) of Natural Gas?
Ensure brevity in your answer.  3.41. What is the difference between the highest and the lowest Mineral Rent(as % of GDP) of Oil?
Your response must be concise. 13.62. What is the difference between the highest and the lowest Mineral Rent(as % of GDP) of Other Minerals?
Ensure brevity in your answer.  1.84. 